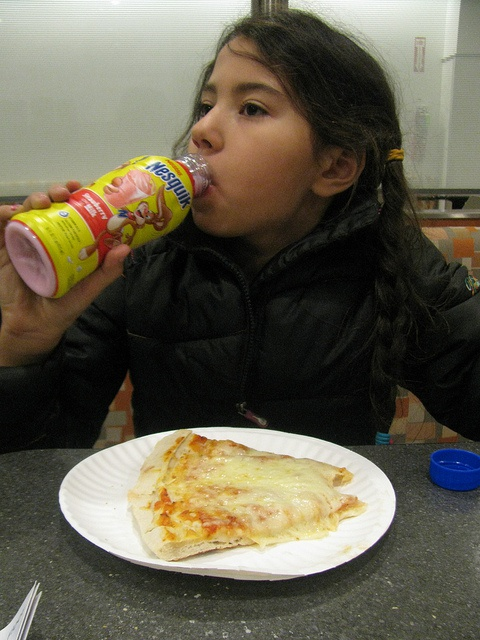Describe the objects in this image and their specific colors. I can see people in lightgray, black, maroon, and gray tones, dining table in lightgray, gray, ivory, black, and khaki tones, pizza in lightgray, khaki, tan, and orange tones, and bottle in lightgray, olive, gray, and maroon tones in this image. 